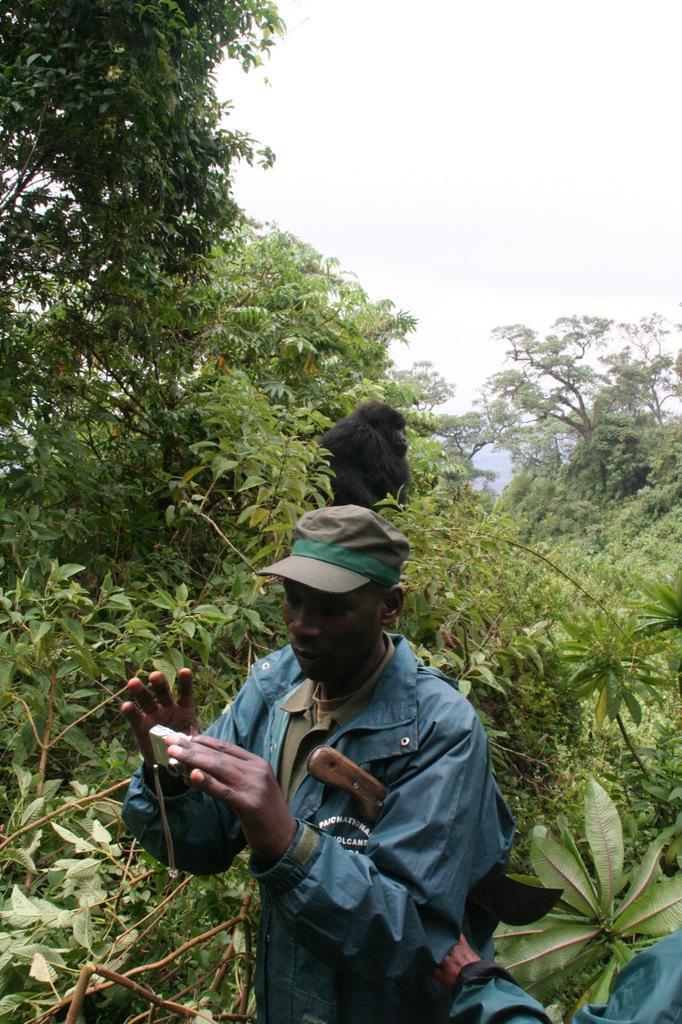Describe this image in one or two sentences. In this image I can see a person. I can see an animal. In the background, I can see the trees and the sky. 